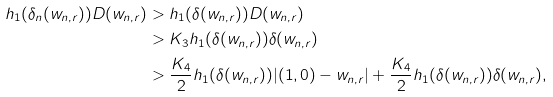<formula> <loc_0><loc_0><loc_500><loc_500>h _ { 1 } ( \delta _ { n } ( w _ { n , r } ) ) D ( w _ { n , r } ) & > h _ { 1 } ( \delta ( w _ { n , r } ) ) D ( w _ { n , r } ) \\ & > K _ { 3 } h _ { 1 } ( \delta ( w _ { n , r } ) ) \delta ( w _ { n , r } ) \\ & > \frac { K _ { 4 } } { 2 } h _ { 1 } ( \delta ( w _ { n , r } ) ) | ( 1 , 0 ) - w _ { n , r } | + \frac { K _ { 4 } } { 2 } h _ { 1 } ( \delta ( w _ { n , r } ) ) \delta ( w _ { n , r } ) ,</formula> 